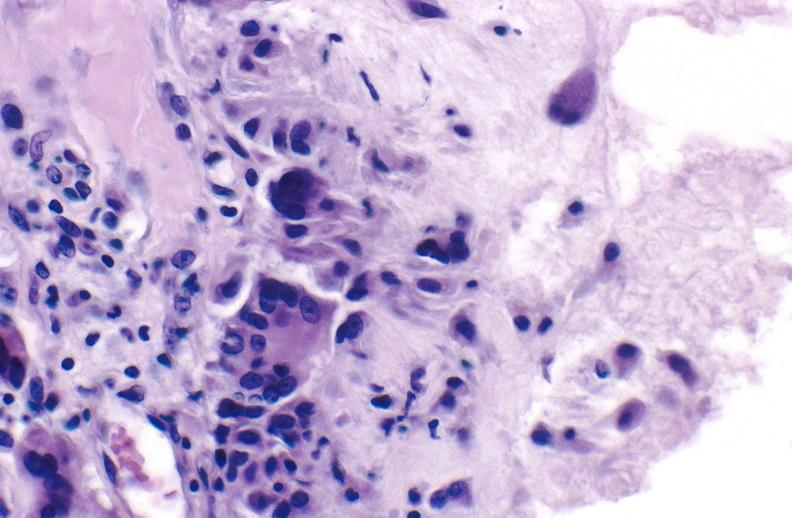s fixed lesions present?
Answer the question using a single word or phrase. No 